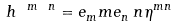Convert formula to latex. <formula><loc_0><loc_0><loc_500><loc_500>h ^ { \ m \ n } = e _ { m } ^ { \ } m e _ { n } ^ { \ } n \eta ^ { m n }</formula> 